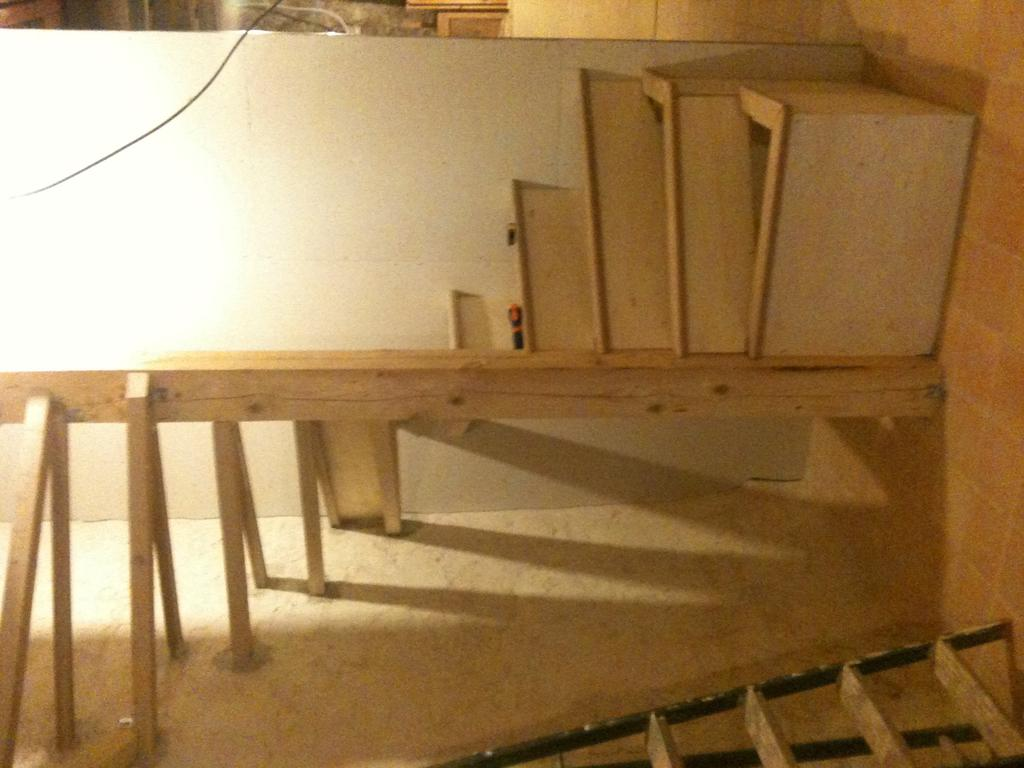What type of objects are on the wooden table in the image? There are wooden objects on a wooden table in the image. What is the tall, vertical object in the image? There is a ladder in the image. What is the flat, rectangular object in the image? There is a wooden sheet in the image. What type of window is present in the image? There is a glass window in the image. Can you see a tiger walking on the wooden sheet in the image? No, there is no tiger present in the image. What direction is the wheel facing in the image? There is no wheel present in the image. 